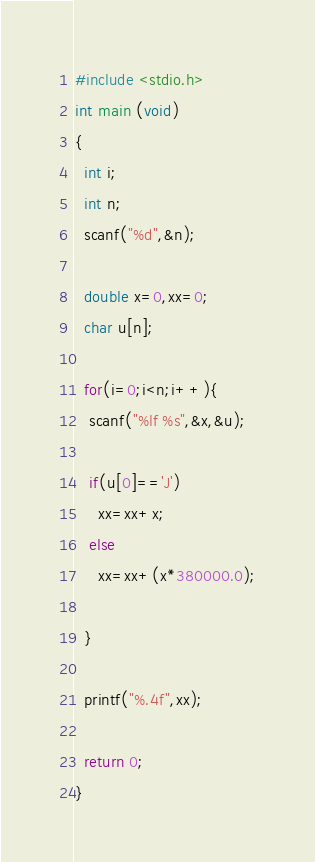<code> <loc_0><loc_0><loc_500><loc_500><_C_>#include <stdio.h>
int main (void)
{
  int i;
  int n;
  scanf("%d",&n);
  
  double x=0,xx=0;
  char u[n];
  
  for(i=0;i<n;i++){
   scanf("%lf %s",&x,&u);
    
   if(u[0]=='J')
     xx=xx+x;
   else
     xx=xx+(x*380000.0);
  
  }
  
  printf("%.4f",xx);
  
  return 0;
}</code> 